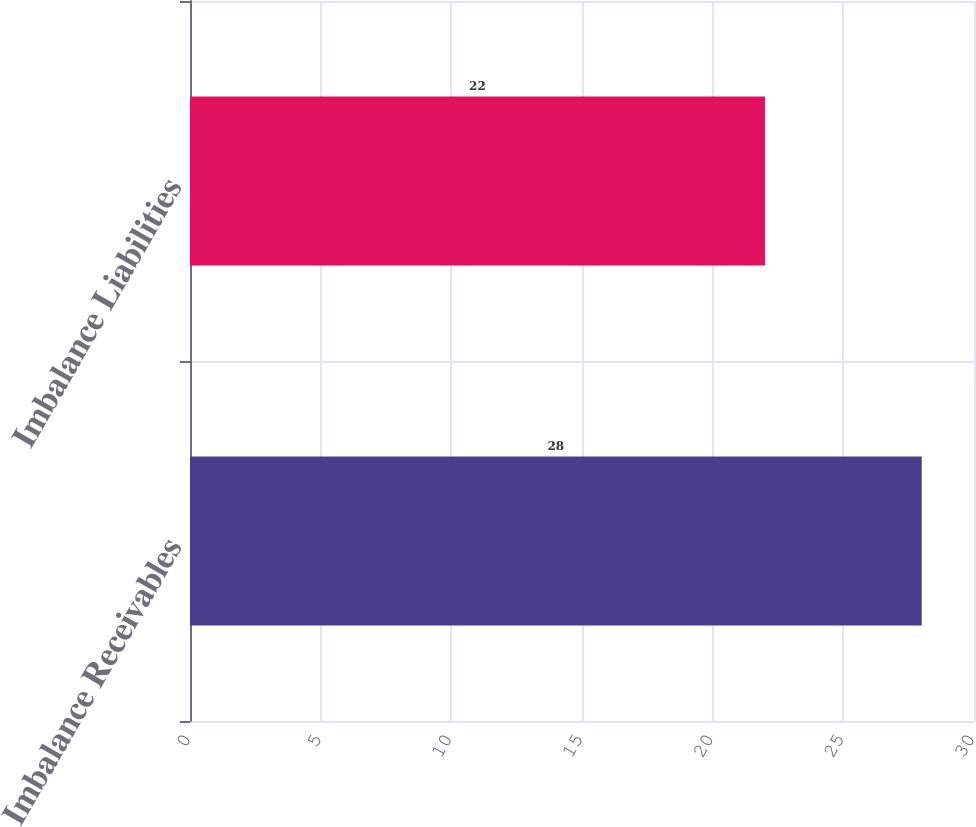Convert chart to OTSL. <chart><loc_0><loc_0><loc_500><loc_500><bar_chart><fcel>Imbalance Receivables<fcel>Imbalance Liabilities<nl><fcel>28<fcel>22<nl></chart> 